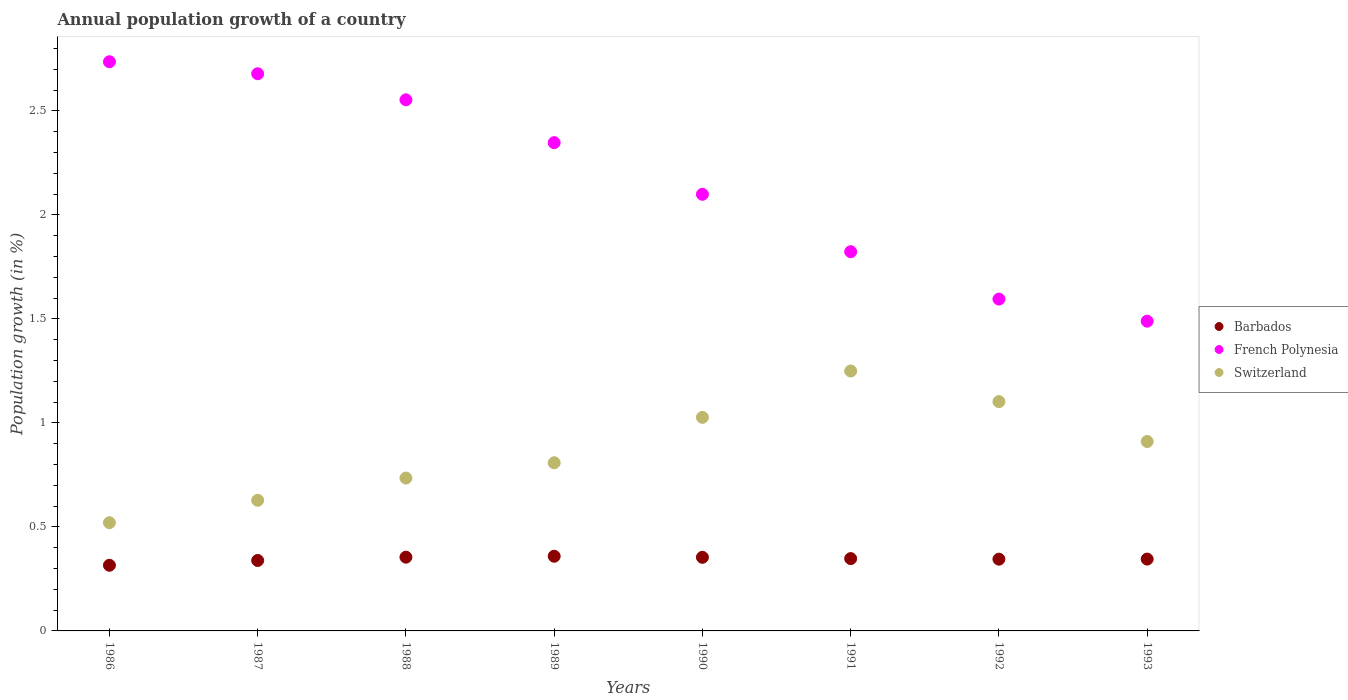How many different coloured dotlines are there?
Your response must be concise. 3. What is the annual population growth in French Polynesia in 1987?
Give a very brief answer. 2.68. Across all years, what is the maximum annual population growth in Switzerland?
Keep it short and to the point. 1.25. Across all years, what is the minimum annual population growth in French Polynesia?
Make the answer very short. 1.49. What is the total annual population growth in Barbados in the graph?
Provide a succinct answer. 2.76. What is the difference between the annual population growth in Barbados in 1989 and that in 1990?
Your response must be concise. 0.01. What is the difference between the annual population growth in Switzerland in 1991 and the annual population growth in Barbados in 1987?
Offer a very short reply. 0.91. What is the average annual population growth in Switzerland per year?
Ensure brevity in your answer.  0.87. In the year 1989, what is the difference between the annual population growth in Switzerland and annual population growth in French Polynesia?
Provide a succinct answer. -1.54. In how many years, is the annual population growth in French Polynesia greater than 0.8 %?
Your answer should be very brief. 8. What is the ratio of the annual population growth in French Polynesia in 1986 to that in 1990?
Offer a very short reply. 1.3. Is the annual population growth in French Polynesia in 1988 less than that in 1992?
Ensure brevity in your answer.  No. What is the difference between the highest and the second highest annual population growth in Barbados?
Your answer should be compact. 0. What is the difference between the highest and the lowest annual population growth in Barbados?
Offer a very short reply. 0.04. In how many years, is the annual population growth in French Polynesia greater than the average annual population growth in French Polynesia taken over all years?
Provide a short and direct response. 4. Is it the case that in every year, the sum of the annual population growth in Switzerland and annual population growth in Barbados  is greater than the annual population growth in French Polynesia?
Keep it short and to the point. No. Does the annual population growth in Barbados monotonically increase over the years?
Your answer should be very brief. No. Is the annual population growth in French Polynesia strictly greater than the annual population growth in Barbados over the years?
Give a very brief answer. Yes. How many dotlines are there?
Give a very brief answer. 3. How many years are there in the graph?
Give a very brief answer. 8. What is the difference between two consecutive major ticks on the Y-axis?
Keep it short and to the point. 0.5. Does the graph contain any zero values?
Offer a very short reply. No. What is the title of the graph?
Your answer should be very brief. Annual population growth of a country. What is the label or title of the X-axis?
Your answer should be very brief. Years. What is the label or title of the Y-axis?
Keep it short and to the point. Population growth (in %). What is the Population growth (in %) in Barbados in 1986?
Keep it short and to the point. 0.32. What is the Population growth (in %) of French Polynesia in 1986?
Offer a very short reply. 2.74. What is the Population growth (in %) in Switzerland in 1986?
Offer a very short reply. 0.52. What is the Population growth (in %) in Barbados in 1987?
Provide a short and direct response. 0.34. What is the Population growth (in %) of French Polynesia in 1987?
Offer a very short reply. 2.68. What is the Population growth (in %) in Switzerland in 1987?
Provide a short and direct response. 0.63. What is the Population growth (in %) in Barbados in 1988?
Your answer should be very brief. 0.35. What is the Population growth (in %) in French Polynesia in 1988?
Your answer should be compact. 2.55. What is the Population growth (in %) of Switzerland in 1988?
Ensure brevity in your answer.  0.73. What is the Population growth (in %) in Barbados in 1989?
Provide a succinct answer. 0.36. What is the Population growth (in %) of French Polynesia in 1989?
Your response must be concise. 2.35. What is the Population growth (in %) of Switzerland in 1989?
Give a very brief answer. 0.81. What is the Population growth (in %) in Barbados in 1990?
Offer a very short reply. 0.35. What is the Population growth (in %) in French Polynesia in 1990?
Offer a terse response. 2.1. What is the Population growth (in %) of Switzerland in 1990?
Ensure brevity in your answer.  1.03. What is the Population growth (in %) in Barbados in 1991?
Offer a very short reply. 0.35. What is the Population growth (in %) of French Polynesia in 1991?
Keep it short and to the point. 1.82. What is the Population growth (in %) of Switzerland in 1991?
Offer a terse response. 1.25. What is the Population growth (in %) in Barbados in 1992?
Your answer should be compact. 0.35. What is the Population growth (in %) in French Polynesia in 1992?
Your answer should be compact. 1.6. What is the Population growth (in %) of Switzerland in 1992?
Provide a short and direct response. 1.1. What is the Population growth (in %) of Barbados in 1993?
Ensure brevity in your answer.  0.35. What is the Population growth (in %) in French Polynesia in 1993?
Your response must be concise. 1.49. What is the Population growth (in %) of Switzerland in 1993?
Ensure brevity in your answer.  0.91. Across all years, what is the maximum Population growth (in %) of Barbados?
Keep it short and to the point. 0.36. Across all years, what is the maximum Population growth (in %) of French Polynesia?
Your answer should be very brief. 2.74. Across all years, what is the maximum Population growth (in %) of Switzerland?
Keep it short and to the point. 1.25. Across all years, what is the minimum Population growth (in %) of Barbados?
Make the answer very short. 0.32. Across all years, what is the minimum Population growth (in %) of French Polynesia?
Your answer should be compact. 1.49. Across all years, what is the minimum Population growth (in %) in Switzerland?
Ensure brevity in your answer.  0.52. What is the total Population growth (in %) in Barbados in the graph?
Your response must be concise. 2.76. What is the total Population growth (in %) in French Polynesia in the graph?
Provide a succinct answer. 17.32. What is the total Population growth (in %) of Switzerland in the graph?
Make the answer very short. 6.98. What is the difference between the Population growth (in %) of Barbados in 1986 and that in 1987?
Provide a short and direct response. -0.02. What is the difference between the Population growth (in %) of French Polynesia in 1986 and that in 1987?
Offer a very short reply. 0.06. What is the difference between the Population growth (in %) in Switzerland in 1986 and that in 1987?
Your response must be concise. -0.11. What is the difference between the Population growth (in %) of Barbados in 1986 and that in 1988?
Your answer should be compact. -0.04. What is the difference between the Population growth (in %) of French Polynesia in 1986 and that in 1988?
Your answer should be very brief. 0.18. What is the difference between the Population growth (in %) of Switzerland in 1986 and that in 1988?
Ensure brevity in your answer.  -0.21. What is the difference between the Population growth (in %) in Barbados in 1986 and that in 1989?
Keep it short and to the point. -0.04. What is the difference between the Population growth (in %) in French Polynesia in 1986 and that in 1989?
Keep it short and to the point. 0.39. What is the difference between the Population growth (in %) of Switzerland in 1986 and that in 1989?
Your answer should be very brief. -0.29. What is the difference between the Population growth (in %) in Barbados in 1986 and that in 1990?
Offer a terse response. -0.04. What is the difference between the Population growth (in %) of French Polynesia in 1986 and that in 1990?
Make the answer very short. 0.64. What is the difference between the Population growth (in %) in Switzerland in 1986 and that in 1990?
Provide a succinct answer. -0.51. What is the difference between the Population growth (in %) in Barbados in 1986 and that in 1991?
Provide a succinct answer. -0.03. What is the difference between the Population growth (in %) of French Polynesia in 1986 and that in 1991?
Provide a succinct answer. 0.91. What is the difference between the Population growth (in %) of Switzerland in 1986 and that in 1991?
Your answer should be very brief. -0.73. What is the difference between the Population growth (in %) of Barbados in 1986 and that in 1992?
Your answer should be very brief. -0.03. What is the difference between the Population growth (in %) of French Polynesia in 1986 and that in 1992?
Offer a terse response. 1.14. What is the difference between the Population growth (in %) in Switzerland in 1986 and that in 1992?
Make the answer very short. -0.58. What is the difference between the Population growth (in %) of Barbados in 1986 and that in 1993?
Provide a short and direct response. -0.03. What is the difference between the Population growth (in %) of French Polynesia in 1986 and that in 1993?
Ensure brevity in your answer.  1.25. What is the difference between the Population growth (in %) of Switzerland in 1986 and that in 1993?
Offer a terse response. -0.39. What is the difference between the Population growth (in %) in Barbados in 1987 and that in 1988?
Your response must be concise. -0.02. What is the difference between the Population growth (in %) in French Polynesia in 1987 and that in 1988?
Provide a succinct answer. 0.13. What is the difference between the Population growth (in %) in Switzerland in 1987 and that in 1988?
Your answer should be very brief. -0.11. What is the difference between the Population growth (in %) in Barbados in 1987 and that in 1989?
Offer a terse response. -0.02. What is the difference between the Population growth (in %) of French Polynesia in 1987 and that in 1989?
Ensure brevity in your answer.  0.33. What is the difference between the Population growth (in %) in Switzerland in 1987 and that in 1989?
Keep it short and to the point. -0.18. What is the difference between the Population growth (in %) of Barbados in 1987 and that in 1990?
Give a very brief answer. -0.02. What is the difference between the Population growth (in %) in French Polynesia in 1987 and that in 1990?
Make the answer very short. 0.58. What is the difference between the Population growth (in %) of Switzerland in 1987 and that in 1990?
Give a very brief answer. -0.4. What is the difference between the Population growth (in %) in Barbados in 1987 and that in 1991?
Give a very brief answer. -0.01. What is the difference between the Population growth (in %) in French Polynesia in 1987 and that in 1991?
Ensure brevity in your answer.  0.86. What is the difference between the Population growth (in %) in Switzerland in 1987 and that in 1991?
Offer a very short reply. -0.62. What is the difference between the Population growth (in %) of Barbados in 1987 and that in 1992?
Keep it short and to the point. -0.01. What is the difference between the Population growth (in %) in French Polynesia in 1987 and that in 1992?
Offer a very short reply. 1.08. What is the difference between the Population growth (in %) in Switzerland in 1987 and that in 1992?
Provide a short and direct response. -0.47. What is the difference between the Population growth (in %) in Barbados in 1987 and that in 1993?
Make the answer very short. -0.01. What is the difference between the Population growth (in %) in French Polynesia in 1987 and that in 1993?
Offer a terse response. 1.19. What is the difference between the Population growth (in %) in Switzerland in 1987 and that in 1993?
Your answer should be very brief. -0.28. What is the difference between the Population growth (in %) in Barbados in 1988 and that in 1989?
Offer a very short reply. -0. What is the difference between the Population growth (in %) of French Polynesia in 1988 and that in 1989?
Your answer should be very brief. 0.21. What is the difference between the Population growth (in %) of Switzerland in 1988 and that in 1989?
Your answer should be compact. -0.07. What is the difference between the Population growth (in %) of Barbados in 1988 and that in 1990?
Make the answer very short. 0. What is the difference between the Population growth (in %) in French Polynesia in 1988 and that in 1990?
Provide a short and direct response. 0.45. What is the difference between the Population growth (in %) in Switzerland in 1988 and that in 1990?
Your answer should be very brief. -0.29. What is the difference between the Population growth (in %) of Barbados in 1988 and that in 1991?
Ensure brevity in your answer.  0.01. What is the difference between the Population growth (in %) of French Polynesia in 1988 and that in 1991?
Make the answer very short. 0.73. What is the difference between the Population growth (in %) in Switzerland in 1988 and that in 1991?
Provide a short and direct response. -0.51. What is the difference between the Population growth (in %) of Barbados in 1988 and that in 1992?
Provide a succinct answer. 0.01. What is the difference between the Population growth (in %) of French Polynesia in 1988 and that in 1992?
Make the answer very short. 0.96. What is the difference between the Population growth (in %) of Switzerland in 1988 and that in 1992?
Your response must be concise. -0.37. What is the difference between the Population growth (in %) of Barbados in 1988 and that in 1993?
Your answer should be compact. 0.01. What is the difference between the Population growth (in %) in French Polynesia in 1988 and that in 1993?
Ensure brevity in your answer.  1.06. What is the difference between the Population growth (in %) of Switzerland in 1988 and that in 1993?
Keep it short and to the point. -0.18. What is the difference between the Population growth (in %) in Barbados in 1989 and that in 1990?
Offer a terse response. 0.01. What is the difference between the Population growth (in %) in French Polynesia in 1989 and that in 1990?
Your response must be concise. 0.25. What is the difference between the Population growth (in %) in Switzerland in 1989 and that in 1990?
Your answer should be compact. -0.22. What is the difference between the Population growth (in %) in Barbados in 1989 and that in 1991?
Your response must be concise. 0.01. What is the difference between the Population growth (in %) of French Polynesia in 1989 and that in 1991?
Offer a terse response. 0.52. What is the difference between the Population growth (in %) of Switzerland in 1989 and that in 1991?
Ensure brevity in your answer.  -0.44. What is the difference between the Population growth (in %) in Barbados in 1989 and that in 1992?
Offer a very short reply. 0.01. What is the difference between the Population growth (in %) of French Polynesia in 1989 and that in 1992?
Offer a very short reply. 0.75. What is the difference between the Population growth (in %) in Switzerland in 1989 and that in 1992?
Offer a terse response. -0.29. What is the difference between the Population growth (in %) of Barbados in 1989 and that in 1993?
Ensure brevity in your answer.  0.01. What is the difference between the Population growth (in %) in French Polynesia in 1989 and that in 1993?
Give a very brief answer. 0.86. What is the difference between the Population growth (in %) in Switzerland in 1989 and that in 1993?
Your answer should be compact. -0.1. What is the difference between the Population growth (in %) of Barbados in 1990 and that in 1991?
Make the answer very short. 0.01. What is the difference between the Population growth (in %) of French Polynesia in 1990 and that in 1991?
Your answer should be very brief. 0.28. What is the difference between the Population growth (in %) in Switzerland in 1990 and that in 1991?
Offer a terse response. -0.22. What is the difference between the Population growth (in %) in Barbados in 1990 and that in 1992?
Offer a very short reply. 0.01. What is the difference between the Population growth (in %) in French Polynesia in 1990 and that in 1992?
Your response must be concise. 0.5. What is the difference between the Population growth (in %) of Switzerland in 1990 and that in 1992?
Your response must be concise. -0.08. What is the difference between the Population growth (in %) in Barbados in 1990 and that in 1993?
Your answer should be compact. 0.01. What is the difference between the Population growth (in %) of French Polynesia in 1990 and that in 1993?
Provide a succinct answer. 0.61. What is the difference between the Population growth (in %) in Switzerland in 1990 and that in 1993?
Keep it short and to the point. 0.12. What is the difference between the Population growth (in %) of Barbados in 1991 and that in 1992?
Ensure brevity in your answer.  0. What is the difference between the Population growth (in %) in French Polynesia in 1991 and that in 1992?
Give a very brief answer. 0.23. What is the difference between the Population growth (in %) in Switzerland in 1991 and that in 1992?
Offer a terse response. 0.15. What is the difference between the Population growth (in %) in Barbados in 1991 and that in 1993?
Ensure brevity in your answer.  0. What is the difference between the Population growth (in %) in French Polynesia in 1991 and that in 1993?
Provide a short and direct response. 0.33. What is the difference between the Population growth (in %) of Switzerland in 1991 and that in 1993?
Offer a very short reply. 0.34. What is the difference between the Population growth (in %) in Barbados in 1992 and that in 1993?
Keep it short and to the point. -0. What is the difference between the Population growth (in %) in French Polynesia in 1992 and that in 1993?
Offer a terse response. 0.11. What is the difference between the Population growth (in %) in Switzerland in 1992 and that in 1993?
Provide a succinct answer. 0.19. What is the difference between the Population growth (in %) of Barbados in 1986 and the Population growth (in %) of French Polynesia in 1987?
Give a very brief answer. -2.36. What is the difference between the Population growth (in %) of Barbados in 1986 and the Population growth (in %) of Switzerland in 1987?
Keep it short and to the point. -0.31. What is the difference between the Population growth (in %) in French Polynesia in 1986 and the Population growth (in %) in Switzerland in 1987?
Keep it short and to the point. 2.11. What is the difference between the Population growth (in %) in Barbados in 1986 and the Population growth (in %) in French Polynesia in 1988?
Your response must be concise. -2.24. What is the difference between the Population growth (in %) of Barbados in 1986 and the Population growth (in %) of Switzerland in 1988?
Your answer should be very brief. -0.42. What is the difference between the Population growth (in %) in French Polynesia in 1986 and the Population growth (in %) in Switzerland in 1988?
Your answer should be compact. 2. What is the difference between the Population growth (in %) in Barbados in 1986 and the Population growth (in %) in French Polynesia in 1989?
Offer a terse response. -2.03. What is the difference between the Population growth (in %) of Barbados in 1986 and the Population growth (in %) of Switzerland in 1989?
Offer a very short reply. -0.49. What is the difference between the Population growth (in %) in French Polynesia in 1986 and the Population growth (in %) in Switzerland in 1989?
Your answer should be very brief. 1.93. What is the difference between the Population growth (in %) of Barbados in 1986 and the Population growth (in %) of French Polynesia in 1990?
Offer a terse response. -1.78. What is the difference between the Population growth (in %) of Barbados in 1986 and the Population growth (in %) of Switzerland in 1990?
Offer a terse response. -0.71. What is the difference between the Population growth (in %) in French Polynesia in 1986 and the Population growth (in %) in Switzerland in 1990?
Give a very brief answer. 1.71. What is the difference between the Population growth (in %) in Barbados in 1986 and the Population growth (in %) in French Polynesia in 1991?
Make the answer very short. -1.51. What is the difference between the Population growth (in %) in Barbados in 1986 and the Population growth (in %) in Switzerland in 1991?
Your answer should be compact. -0.93. What is the difference between the Population growth (in %) in French Polynesia in 1986 and the Population growth (in %) in Switzerland in 1991?
Your answer should be very brief. 1.49. What is the difference between the Population growth (in %) of Barbados in 1986 and the Population growth (in %) of French Polynesia in 1992?
Your response must be concise. -1.28. What is the difference between the Population growth (in %) of Barbados in 1986 and the Population growth (in %) of Switzerland in 1992?
Provide a succinct answer. -0.79. What is the difference between the Population growth (in %) in French Polynesia in 1986 and the Population growth (in %) in Switzerland in 1992?
Your response must be concise. 1.63. What is the difference between the Population growth (in %) in Barbados in 1986 and the Population growth (in %) in French Polynesia in 1993?
Offer a very short reply. -1.17. What is the difference between the Population growth (in %) in Barbados in 1986 and the Population growth (in %) in Switzerland in 1993?
Give a very brief answer. -0.6. What is the difference between the Population growth (in %) in French Polynesia in 1986 and the Population growth (in %) in Switzerland in 1993?
Offer a terse response. 1.83. What is the difference between the Population growth (in %) of Barbados in 1987 and the Population growth (in %) of French Polynesia in 1988?
Make the answer very short. -2.21. What is the difference between the Population growth (in %) of Barbados in 1987 and the Population growth (in %) of Switzerland in 1988?
Offer a terse response. -0.4. What is the difference between the Population growth (in %) of French Polynesia in 1987 and the Population growth (in %) of Switzerland in 1988?
Give a very brief answer. 1.94. What is the difference between the Population growth (in %) of Barbados in 1987 and the Population growth (in %) of French Polynesia in 1989?
Your answer should be compact. -2.01. What is the difference between the Population growth (in %) in Barbados in 1987 and the Population growth (in %) in Switzerland in 1989?
Keep it short and to the point. -0.47. What is the difference between the Population growth (in %) in French Polynesia in 1987 and the Population growth (in %) in Switzerland in 1989?
Ensure brevity in your answer.  1.87. What is the difference between the Population growth (in %) in Barbados in 1987 and the Population growth (in %) in French Polynesia in 1990?
Your answer should be compact. -1.76. What is the difference between the Population growth (in %) in Barbados in 1987 and the Population growth (in %) in Switzerland in 1990?
Provide a succinct answer. -0.69. What is the difference between the Population growth (in %) in French Polynesia in 1987 and the Population growth (in %) in Switzerland in 1990?
Provide a succinct answer. 1.65. What is the difference between the Population growth (in %) of Barbados in 1987 and the Population growth (in %) of French Polynesia in 1991?
Make the answer very short. -1.48. What is the difference between the Population growth (in %) of Barbados in 1987 and the Population growth (in %) of Switzerland in 1991?
Give a very brief answer. -0.91. What is the difference between the Population growth (in %) in French Polynesia in 1987 and the Population growth (in %) in Switzerland in 1991?
Ensure brevity in your answer.  1.43. What is the difference between the Population growth (in %) in Barbados in 1987 and the Population growth (in %) in French Polynesia in 1992?
Ensure brevity in your answer.  -1.26. What is the difference between the Population growth (in %) of Barbados in 1987 and the Population growth (in %) of Switzerland in 1992?
Make the answer very short. -0.76. What is the difference between the Population growth (in %) of French Polynesia in 1987 and the Population growth (in %) of Switzerland in 1992?
Offer a very short reply. 1.58. What is the difference between the Population growth (in %) of Barbados in 1987 and the Population growth (in %) of French Polynesia in 1993?
Your answer should be compact. -1.15. What is the difference between the Population growth (in %) of Barbados in 1987 and the Population growth (in %) of Switzerland in 1993?
Make the answer very short. -0.57. What is the difference between the Population growth (in %) of French Polynesia in 1987 and the Population growth (in %) of Switzerland in 1993?
Your answer should be very brief. 1.77. What is the difference between the Population growth (in %) in Barbados in 1988 and the Population growth (in %) in French Polynesia in 1989?
Your answer should be compact. -1.99. What is the difference between the Population growth (in %) of Barbados in 1988 and the Population growth (in %) of Switzerland in 1989?
Provide a short and direct response. -0.45. What is the difference between the Population growth (in %) of French Polynesia in 1988 and the Population growth (in %) of Switzerland in 1989?
Keep it short and to the point. 1.75. What is the difference between the Population growth (in %) in Barbados in 1988 and the Population growth (in %) in French Polynesia in 1990?
Provide a succinct answer. -1.74. What is the difference between the Population growth (in %) in Barbados in 1988 and the Population growth (in %) in Switzerland in 1990?
Ensure brevity in your answer.  -0.67. What is the difference between the Population growth (in %) of French Polynesia in 1988 and the Population growth (in %) of Switzerland in 1990?
Offer a terse response. 1.53. What is the difference between the Population growth (in %) in Barbados in 1988 and the Population growth (in %) in French Polynesia in 1991?
Offer a very short reply. -1.47. What is the difference between the Population growth (in %) of Barbados in 1988 and the Population growth (in %) of Switzerland in 1991?
Make the answer very short. -0.9. What is the difference between the Population growth (in %) of French Polynesia in 1988 and the Population growth (in %) of Switzerland in 1991?
Provide a short and direct response. 1.3. What is the difference between the Population growth (in %) of Barbados in 1988 and the Population growth (in %) of French Polynesia in 1992?
Your answer should be compact. -1.24. What is the difference between the Population growth (in %) of Barbados in 1988 and the Population growth (in %) of Switzerland in 1992?
Your answer should be compact. -0.75. What is the difference between the Population growth (in %) of French Polynesia in 1988 and the Population growth (in %) of Switzerland in 1992?
Your answer should be very brief. 1.45. What is the difference between the Population growth (in %) in Barbados in 1988 and the Population growth (in %) in French Polynesia in 1993?
Offer a terse response. -1.13. What is the difference between the Population growth (in %) of Barbados in 1988 and the Population growth (in %) of Switzerland in 1993?
Offer a very short reply. -0.56. What is the difference between the Population growth (in %) in French Polynesia in 1988 and the Population growth (in %) in Switzerland in 1993?
Provide a succinct answer. 1.64. What is the difference between the Population growth (in %) in Barbados in 1989 and the Population growth (in %) in French Polynesia in 1990?
Your answer should be compact. -1.74. What is the difference between the Population growth (in %) of Barbados in 1989 and the Population growth (in %) of Switzerland in 1990?
Ensure brevity in your answer.  -0.67. What is the difference between the Population growth (in %) in French Polynesia in 1989 and the Population growth (in %) in Switzerland in 1990?
Offer a very short reply. 1.32. What is the difference between the Population growth (in %) in Barbados in 1989 and the Population growth (in %) in French Polynesia in 1991?
Make the answer very short. -1.46. What is the difference between the Population growth (in %) of Barbados in 1989 and the Population growth (in %) of Switzerland in 1991?
Give a very brief answer. -0.89. What is the difference between the Population growth (in %) of French Polynesia in 1989 and the Population growth (in %) of Switzerland in 1991?
Your answer should be very brief. 1.1. What is the difference between the Population growth (in %) in Barbados in 1989 and the Population growth (in %) in French Polynesia in 1992?
Your response must be concise. -1.24. What is the difference between the Population growth (in %) of Barbados in 1989 and the Population growth (in %) of Switzerland in 1992?
Provide a succinct answer. -0.74. What is the difference between the Population growth (in %) in French Polynesia in 1989 and the Population growth (in %) in Switzerland in 1992?
Offer a very short reply. 1.25. What is the difference between the Population growth (in %) of Barbados in 1989 and the Population growth (in %) of French Polynesia in 1993?
Your answer should be very brief. -1.13. What is the difference between the Population growth (in %) of Barbados in 1989 and the Population growth (in %) of Switzerland in 1993?
Ensure brevity in your answer.  -0.55. What is the difference between the Population growth (in %) of French Polynesia in 1989 and the Population growth (in %) of Switzerland in 1993?
Your answer should be compact. 1.44. What is the difference between the Population growth (in %) in Barbados in 1990 and the Population growth (in %) in French Polynesia in 1991?
Keep it short and to the point. -1.47. What is the difference between the Population growth (in %) in Barbados in 1990 and the Population growth (in %) in Switzerland in 1991?
Offer a terse response. -0.9. What is the difference between the Population growth (in %) of French Polynesia in 1990 and the Population growth (in %) of Switzerland in 1991?
Offer a very short reply. 0.85. What is the difference between the Population growth (in %) in Barbados in 1990 and the Population growth (in %) in French Polynesia in 1992?
Offer a terse response. -1.24. What is the difference between the Population growth (in %) of Barbados in 1990 and the Population growth (in %) of Switzerland in 1992?
Offer a terse response. -0.75. What is the difference between the Population growth (in %) in Barbados in 1990 and the Population growth (in %) in French Polynesia in 1993?
Your answer should be compact. -1.14. What is the difference between the Population growth (in %) in Barbados in 1990 and the Population growth (in %) in Switzerland in 1993?
Keep it short and to the point. -0.56. What is the difference between the Population growth (in %) of French Polynesia in 1990 and the Population growth (in %) of Switzerland in 1993?
Provide a succinct answer. 1.19. What is the difference between the Population growth (in %) of Barbados in 1991 and the Population growth (in %) of French Polynesia in 1992?
Your response must be concise. -1.25. What is the difference between the Population growth (in %) of Barbados in 1991 and the Population growth (in %) of Switzerland in 1992?
Your answer should be compact. -0.75. What is the difference between the Population growth (in %) in French Polynesia in 1991 and the Population growth (in %) in Switzerland in 1992?
Make the answer very short. 0.72. What is the difference between the Population growth (in %) in Barbados in 1991 and the Population growth (in %) in French Polynesia in 1993?
Your response must be concise. -1.14. What is the difference between the Population growth (in %) in Barbados in 1991 and the Population growth (in %) in Switzerland in 1993?
Provide a short and direct response. -0.56. What is the difference between the Population growth (in %) in French Polynesia in 1991 and the Population growth (in %) in Switzerland in 1993?
Keep it short and to the point. 0.91. What is the difference between the Population growth (in %) of Barbados in 1992 and the Population growth (in %) of French Polynesia in 1993?
Your answer should be very brief. -1.14. What is the difference between the Population growth (in %) in Barbados in 1992 and the Population growth (in %) in Switzerland in 1993?
Make the answer very short. -0.57. What is the difference between the Population growth (in %) in French Polynesia in 1992 and the Population growth (in %) in Switzerland in 1993?
Provide a short and direct response. 0.68. What is the average Population growth (in %) in Barbados per year?
Ensure brevity in your answer.  0.34. What is the average Population growth (in %) of French Polynesia per year?
Your answer should be very brief. 2.17. What is the average Population growth (in %) of Switzerland per year?
Keep it short and to the point. 0.87. In the year 1986, what is the difference between the Population growth (in %) of Barbados and Population growth (in %) of French Polynesia?
Offer a terse response. -2.42. In the year 1986, what is the difference between the Population growth (in %) in Barbados and Population growth (in %) in Switzerland?
Make the answer very short. -0.2. In the year 1986, what is the difference between the Population growth (in %) of French Polynesia and Population growth (in %) of Switzerland?
Offer a very short reply. 2.22. In the year 1987, what is the difference between the Population growth (in %) in Barbados and Population growth (in %) in French Polynesia?
Provide a short and direct response. -2.34. In the year 1987, what is the difference between the Population growth (in %) in Barbados and Population growth (in %) in Switzerland?
Provide a short and direct response. -0.29. In the year 1987, what is the difference between the Population growth (in %) of French Polynesia and Population growth (in %) of Switzerland?
Make the answer very short. 2.05. In the year 1988, what is the difference between the Population growth (in %) of Barbados and Population growth (in %) of French Polynesia?
Offer a terse response. -2.2. In the year 1988, what is the difference between the Population growth (in %) of Barbados and Population growth (in %) of Switzerland?
Give a very brief answer. -0.38. In the year 1988, what is the difference between the Population growth (in %) of French Polynesia and Population growth (in %) of Switzerland?
Ensure brevity in your answer.  1.82. In the year 1989, what is the difference between the Population growth (in %) in Barbados and Population growth (in %) in French Polynesia?
Give a very brief answer. -1.99. In the year 1989, what is the difference between the Population growth (in %) of Barbados and Population growth (in %) of Switzerland?
Offer a terse response. -0.45. In the year 1989, what is the difference between the Population growth (in %) of French Polynesia and Population growth (in %) of Switzerland?
Make the answer very short. 1.54. In the year 1990, what is the difference between the Population growth (in %) in Barbados and Population growth (in %) in French Polynesia?
Ensure brevity in your answer.  -1.75. In the year 1990, what is the difference between the Population growth (in %) of Barbados and Population growth (in %) of Switzerland?
Provide a succinct answer. -0.67. In the year 1990, what is the difference between the Population growth (in %) in French Polynesia and Population growth (in %) in Switzerland?
Your answer should be compact. 1.07. In the year 1991, what is the difference between the Population growth (in %) of Barbados and Population growth (in %) of French Polynesia?
Give a very brief answer. -1.48. In the year 1991, what is the difference between the Population growth (in %) in Barbados and Population growth (in %) in Switzerland?
Your answer should be very brief. -0.9. In the year 1991, what is the difference between the Population growth (in %) in French Polynesia and Population growth (in %) in Switzerland?
Offer a terse response. 0.57. In the year 1992, what is the difference between the Population growth (in %) of Barbados and Population growth (in %) of French Polynesia?
Keep it short and to the point. -1.25. In the year 1992, what is the difference between the Population growth (in %) in Barbados and Population growth (in %) in Switzerland?
Keep it short and to the point. -0.76. In the year 1992, what is the difference between the Population growth (in %) in French Polynesia and Population growth (in %) in Switzerland?
Give a very brief answer. 0.49. In the year 1993, what is the difference between the Population growth (in %) in Barbados and Population growth (in %) in French Polynesia?
Your response must be concise. -1.14. In the year 1993, what is the difference between the Population growth (in %) in Barbados and Population growth (in %) in Switzerland?
Your answer should be very brief. -0.57. In the year 1993, what is the difference between the Population growth (in %) of French Polynesia and Population growth (in %) of Switzerland?
Make the answer very short. 0.58. What is the ratio of the Population growth (in %) of Barbados in 1986 to that in 1987?
Make the answer very short. 0.93. What is the ratio of the Population growth (in %) of French Polynesia in 1986 to that in 1987?
Offer a very short reply. 1.02. What is the ratio of the Population growth (in %) of Switzerland in 1986 to that in 1987?
Your answer should be very brief. 0.83. What is the ratio of the Population growth (in %) of Barbados in 1986 to that in 1988?
Keep it short and to the point. 0.89. What is the ratio of the Population growth (in %) in French Polynesia in 1986 to that in 1988?
Offer a terse response. 1.07. What is the ratio of the Population growth (in %) of Switzerland in 1986 to that in 1988?
Your answer should be very brief. 0.71. What is the ratio of the Population growth (in %) of Barbados in 1986 to that in 1989?
Provide a succinct answer. 0.88. What is the ratio of the Population growth (in %) of French Polynesia in 1986 to that in 1989?
Offer a very short reply. 1.17. What is the ratio of the Population growth (in %) in Switzerland in 1986 to that in 1989?
Keep it short and to the point. 0.64. What is the ratio of the Population growth (in %) of Barbados in 1986 to that in 1990?
Offer a very short reply. 0.89. What is the ratio of the Population growth (in %) in French Polynesia in 1986 to that in 1990?
Keep it short and to the point. 1.3. What is the ratio of the Population growth (in %) in Switzerland in 1986 to that in 1990?
Your answer should be compact. 0.51. What is the ratio of the Population growth (in %) of Barbados in 1986 to that in 1991?
Offer a terse response. 0.91. What is the ratio of the Population growth (in %) of French Polynesia in 1986 to that in 1991?
Your response must be concise. 1.5. What is the ratio of the Population growth (in %) in Switzerland in 1986 to that in 1991?
Your response must be concise. 0.42. What is the ratio of the Population growth (in %) of Barbados in 1986 to that in 1992?
Offer a very short reply. 0.91. What is the ratio of the Population growth (in %) of French Polynesia in 1986 to that in 1992?
Offer a very short reply. 1.72. What is the ratio of the Population growth (in %) of Switzerland in 1986 to that in 1992?
Your response must be concise. 0.47. What is the ratio of the Population growth (in %) in Barbados in 1986 to that in 1993?
Offer a very short reply. 0.91. What is the ratio of the Population growth (in %) of French Polynesia in 1986 to that in 1993?
Ensure brevity in your answer.  1.84. What is the ratio of the Population growth (in %) of Barbados in 1987 to that in 1988?
Make the answer very short. 0.96. What is the ratio of the Population growth (in %) of French Polynesia in 1987 to that in 1988?
Your answer should be compact. 1.05. What is the ratio of the Population growth (in %) of Switzerland in 1987 to that in 1988?
Provide a succinct answer. 0.85. What is the ratio of the Population growth (in %) in Barbados in 1987 to that in 1989?
Offer a terse response. 0.94. What is the ratio of the Population growth (in %) in French Polynesia in 1987 to that in 1989?
Your answer should be compact. 1.14. What is the ratio of the Population growth (in %) of Switzerland in 1987 to that in 1989?
Ensure brevity in your answer.  0.78. What is the ratio of the Population growth (in %) in Barbados in 1987 to that in 1990?
Keep it short and to the point. 0.96. What is the ratio of the Population growth (in %) of French Polynesia in 1987 to that in 1990?
Offer a terse response. 1.28. What is the ratio of the Population growth (in %) in Switzerland in 1987 to that in 1990?
Ensure brevity in your answer.  0.61. What is the ratio of the Population growth (in %) of French Polynesia in 1987 to that in 1991?
Your answer should be compact. 1.47. What is the ratio of the Population growth (in %) of Switzerland in 1987 to that in 1991?
Ensure brevity in your answer.  0.5. What is the ratio of the Population growth (in %) in Barbados in 1987 to that in 1992?
Your answer should be compact. 0.98. What is the ratio of the Population growth (in %) in French Polynesia in 1987 to that in 1992?
Your answer should be compact. 1.68. What is the ratio of the Population growth (in %) of Switzerland in 1987 to that in 1992?
Make the answer very short. 0.57. What is the ratio of the Population growth (in %) in Barbados in 1987 to that in 1993?
Ensure brevity in your answer.  0.98. What is the ratio of the Population growth (in %) of French Polynesia in 1987 to that in 1993?
Provide a succinct answer. 1.8. What is the ratio of the Population growth (in %) of Switzerland in 1987 to that in 1993?
Keep it short and to the point. 0.69. What is the ratio of the Population growth (in %) of Barbados in 1988 to that in 1989?
Make the answer very short. 0.99. What is the ratio of the Population growth (in %) in French Polynesia in 1988 to that in 1989?
Give a very brief answer. 1.09. What is the ratio of the Population growth (in %) in Switzerland in 1988 to that in 1989?
Your answer should be very brief. 0.91. What is the ratio of the Population growth (in %) of Barbados in 1988 to that in 1990?
Make the answer very short. 1. What is the ratio of the Population growth (in %) of French Polynesia in 1988 to that in 1990?
Give a very brief answer. 1.22. What is the ratio of the Population growth (in %) in Switzerland in 1988 to that in 1990?
Keep it short and to the point. 0.72. What is the ratio of the Population growth (in %) in Barbados in 1988 to that in 1991?
Ensure brevity in your answer.  1.02. What is the ratio of the Population growth (in %) in French Polynesia in 1988 to that in 1991?
Your answer should be compact. 1.4. What is the ratio of the Population growth (in %) of Switzerland in 1988 to that in 1991?
Ensure brevity in your answer.  0.59. What is the ratio of the Population growth (in %) in Barbados in 1988 to that in 1992?
Ensure brevity in your answer.  1.03. What is the ratio of the Population growth (in %) of French Polynesia in 1988 to that in 1992?
Your answer should be compact. 1.6. What is the ratio of the Population growth (in %) of Switzerland in 1988 to that in 1992?
Make the answer very short. 0.67. What is the ratio of the Population growth (in %) of Barbados in 1988 to that in 1993?
Offer a very short reply. 1.03. What is the ratio of the Population growth (in %) of French Polynesia in 1988 to that in 1993?
Your answer should be compact. 1.71. What is the ratio of the Population growth (in %) of Switzerland in 1988 to that in 1993?
Your answer should be very brief. 0.81. What is the ratio of the Population growth (in %) of Barbados in 1989 to that in 1990?
Provide a short and direct response. 1.01. What is the ratio of the Population growth (in %) of French Polynesia in 1989 to that in 1990?
Make the answer very short. 1.12. What is the ratio of the Population growth (in %) in Switzerland in 1989 to that in 1990?
Offer a terse response. 0.79. What is the ratio of the Population growth (in %) of Barbados in 1989 to that in 1991?
Make the answer very short. 1.03. What is the ratio of the Population growth (in %) of French Polynesia in 1989 to that in 1991?
Keep it short and to the point. 1.29. What is the ratio of the Population growth (in %) in Switzerland in 1989 to that in 1991?
Give a very brief answer. 0.65. What is the ratio of the Population growth (in %) of Barbados in 1989 to that in 1992?
Provide a succinct answer. 1.04. What is the ratio of the Population growth (in %) of French Polynesia in 1989 to that in 1992?
Offer a very short reply. 1.47. What is the ratio of the Population growth (in %) in Switzerland in 1989 to that in 1992?
Give a very brief answer. 0.73. What is the ratio of the Population growth (in %) in Barbados in 1989 to that in 1993?
Provide a succinct answer. 1.04. What is the ratio of the Population growth (in %) of French Polynesia in 1989 to that in 1993?
Your answer should be very brief. 1.58. What is the ratio of the Population growth (in %) of Switzerland in 1989 to that in 1993?
Ensure brevity in your answer.  0.89. What is the ratio of the Population growth (in %) in Barbados in 1990 to that in 1991?
Provide a short and direct response. 1.02. What is the ratio of the Population growth (in %) of French Polynesia in 1990 to that in 1991?
Keep it short and to the point. 1.15. What is the ratio of the Population growth (in %) of Switzerland in 1990 to that in 1991?
Keep it short and to the point. 0.82. What is the ratio of the Population growth (in %) of Barbados in 1990 to that in 1992?
Give a very brief answer. 1.03. What is the ratio of the Population growth (in %) of French Polynesia in 1990 to that in 1992?
Your answer should be very brief. 1.32. What is the ratio of the Population growth (in %) of Switzerland in 1990 to that in 1992?
Provide a succinct answer. 0.93. What is the ratio of the Population growth (in %) in French Polynesia in 1990 to that in 1993?
Offer a terse response. 1.41. What is the ratio of the Population growth (in %) in Switzerland in 1990 to that in 1993?
Provide a succinct answer. 1.13. What is the ratio of the Population growth (in %) in Barbados in 1991 to that in 1992?
Your answer should be compact. 1.01. What is the ratio of the Population growth (in %) of French Polynesia in 1991 to that in 1992?
Provide a short and direct response. 1.14. What is the ratio of the Population growth (in %) in Switzerland in 1991 to that in 1992?
Offer a terse response. 1.13. What is the ratio of the Population growth (in %) in Barbados in 1991 to that in 1993?
Your answer should be compact. 1.01. What is the ratio of the Population growth (in %) in French Polynesia in 1991 to that in 1993?
Keep it short and to the point. 1.22. What is the ratio of the Population growth (in %) in Switzerland in 1991 to that in 1993?
Ensure brevity in your answer.  1.37. What is the ratio of the Population growth (in %) of French Polynesia in 1992 to that in 1993?
Your answer should be very brief. 1.07. What is the ratio of the Population growth (in %) in Switzerland in 1992 to that in 1993?
Offer a terse response. 1.21. What is the difference between the highest and the second highest Population growth (in %) in Barbados?
Provide a succinct answer. 0. What is the difference between the highest and the second highest Population growth (in %) in French Polynesia?
Your answer should be very brief. 0.06. What is the difference between the highest and the second highest Population growth (in %) of Switzerland?
Your response must be concise. 0.15. What is the difference between the highest and the lowest Population growth (in %) of Barbados?
Your answer should be compact. 0.04. What is the difference between the highest and the lowest Population growth (in %) in French Polynesia?
Provide a short and direct response. 1.25. What is the difference between the highest and the lowest Population growth (in %) in Switzerland?
Offer a very short reply. 0.73. 